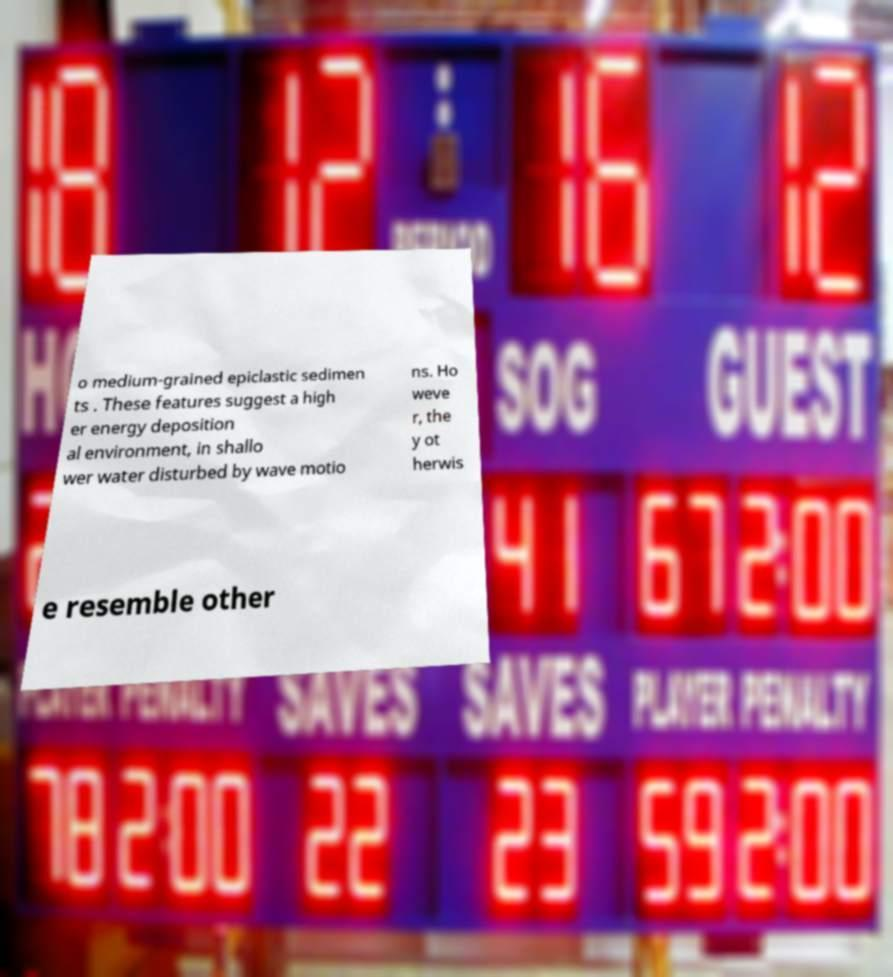There's text embedded in this image that I need extracted. Can you transcribe it verbatim? o medium-grained epiclastic sedimen ts . These features suggest a high er energy deposition al environment, in shallo wer water disturbed by wave motio ns. Ho weve r, the y ot herwis e resemble other 